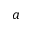<formula> <loc_0><loc_0><loc_500><loc_500>a</formula> 